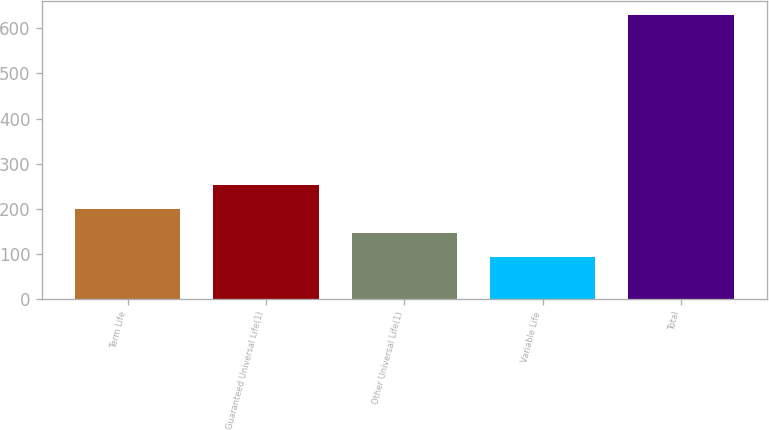<chart> <loc_0><loc_0><loc_500><loc_500><bar_chart><fcel>Term Life<fcel>Guaranteed Universal Life(1)<fcel>Other Universal Life(1)<fcel>Variable Life<fcel>Total<nl><fcel>200<fcel>253.8<fcel>145.8<fcel>92<fcel>630<nl></chart> 